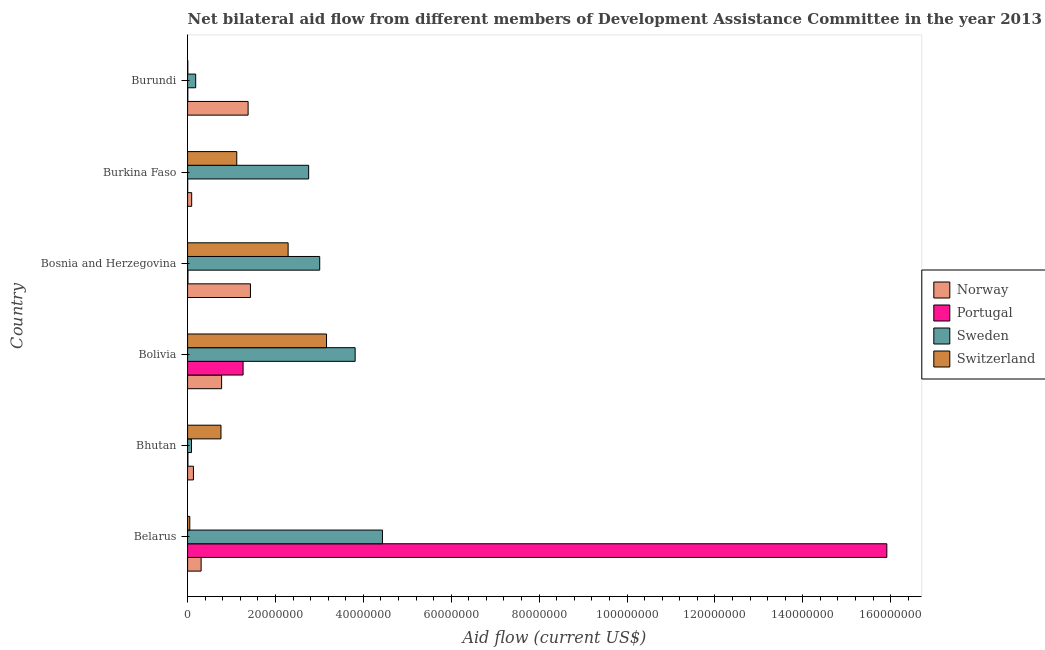How many different coloured bars are there?
Offer a very short reply. 4. How many bars are there on the 4th tick from the top?
Keep it short and to the point. 4. What is the label of the 1st group of bars from the top?
Your answer should be very brief. Burundi. What is the amount of aid given by sweden in Belarus?
Provide a short and direct response. 4.43e+07. Across all countries, what is the maximum amount of aid given by switzerland?
Your answer should be compact. 3.16e+07. Across all countries, what is the minimum amount of aid given by portugal?
Keep it short and to the point. 2.00e+04. In which country was the amount of aid given by sweden maximum?
Your response must be concise. Belarus. In which country was the amount of aid given by sweden minimum?
Provide a short and direct response. Bhutan. What is the total amount of aid given by norway in the graph?
Your response must be concise. 4.12e+07. What is the difference between the amount of aid given by portugal in Bolivia and that in Burkina Faso?
Your answer should be compact. 1.26e+07. What is the difference between the amount of aid given by switzerland in Bosnia and Herzegovina and the amount of aid given by norway in Bolivia?
Give a very brief answer. 1.51e+07. What is the average amount of aid given by sweden per country?
Ensure brevity in your answer.  2.38e+07. What is the difference between the amount of aid given by portugal and amount of aid given by norway in Burundi?
Offer a terse response. -1.37e+07. In how many countries, is the amount of aid given by sweden greater than 80000000 US$?
Ensure brevity in your answer.  0. What is the ratio of the amount of aid given by switzerland in Belarus to that in Bolivia?
Keep it short and to the point. 0.02. Is the amount of aid given by portugal in Bolivia less than that in Burkina Faso?
Make the answer very short. No. Is the difference between the amount of aid given by portugal in Burkina Faso and Burundi greater than the difference between the amount of aid given by switzerland in Burkina Faso and Burundi?
Your answer should be compact. No. What is the difference between the highest and the second highest amount of aid given by sweden?
Your answer should be very brief. 6.21e+06. What is the difference between the highest and the lowest amount of aid given by sweden?
Ensure brevity in your answer.  4.34e+07. In how many countries, is the amount of aid given by norway greater than the average amount of aid given by norway taken over all countries?
Make the answer very short. 3. What does the 1st bar from the top in Belarus represents?
Your answer should be very brief. Switzerland. Is it the case that in every country, the sum of the amount of aid given by norway and amount of aid given by portugal is greater than the amount of aid given by sweden?
Give a very brief answer. No. How many bars are there?
Ensure brevity in your answer.  24. How many countries are there in the graph?
Make the answer very short. 6. What is the difference between two consecutive major ticks on the X-axis?
Your response must be concise. 2.00e+07. Are the values on the major ticks of X-axis written in scientific E-notation?
Your response must be concise. No. Does the graph contain any zero values?
Your answer should be very brief. No. How many legend labels are there?
Your response must be concise. 4. What is the title of the graph?
Your answer should be very brief. Net bilateral aid flow from different members of Development Assistance Committee in the year 2013. Does "Korea" appear as one of the legend labels in the graph?
Your response must be concise. No. What is the label or title of the X-axis?
Offer a terse response. Aid flow (current US$). What is the Aid flow (current US$) of Norway in Belarus?
Give a very brief answer. 3.08e+06. What is the Aid flow (current US$) in Portugal in Belarus?
Provide a succinct answer. 1.59e+08. What is the Aid flow (current US$) in Sweden in Belarus?
Keep it short and to the point. 4.43e+07. What is the Aid flow (current US$) of Switzerland in Belarus?
Your answer should be very brief. 5.00e+05. What is the Aid flow (current US$) in Norway in Bhutan?
Your response must be concise. 1.33e+06. What is the Aid flow (current US$) of Portugal in Bhutan?
Offer a very short reply. 7.00e+04. What is the Aid flow (current US$) in Sweden in Bhutan?
Your response must be concise. 8.90e+05. What is the Aid flow (current US$) of Switzerland in Bhutan?
Provide a short and direct response. 7.60e+06. What is the Aid flow (current US$) in Norway in Bolivia?
Provide a short and direct response. 7.74e+06. What is the Aid flow (current US$) of Portugal in Bolivia?
Offer a terse response. 1.26e+07. What is the Aid flow (current US$) of Sweden in Bolivia?
Offer a very short reply. 3.81e+07. What is the Aid flow (current US$) in Switzerland in Bolivia?
Give a very brief answer. 3.16e+07. What is the Aid flow (current US$) in Norway in Bosnia and Herzegovina?
Keep it short and to the point. 1.43e+07. What is the Aid flow (current US$) of Portugal in Bosnia and Herzegovina?
Your answer should be compact. 8.00e+04. What is the Aid flow (current US$) of Sweden in Bosnia and Herzegovina?
Provide a short and direct response. 3.01e+07. What is the Aid flow (current US$) of Switzerland in Bosnia and Herzegovina?
Your response must be concise. 2.29e+07. What is the Aid flow (current US$) in Norway in Burkina Faso?
Ensure brevity in your answer.  9.30e+05. What is the Aid flow (current US$) of Sweden in Burkina Faso?
Offer a terse response. 2.76e+07. What is the Aid flow (current US$) in Switzerland in Burkina Faso?
Ensure brevity in your answer.  1.12e+07. What is the Aid flow (current US$) in Norway in Burundi?
Offer a very short reply. 1.38e+07. What is the Aid flow (current US$) in Sweden in Burundi?
Give a very brief answer. 1.84e+06. What is the Aid flow (current US$) of Switzerland in Burundi?
Keep it short and to the point. 5.00e+04. Across all countries, what is the maximum Aid flow (current US$) of Norway?
Ensure brevity in your answer.  1.43e+07. Across all countries, what is the maximum Aid flow (current US$) in Portugal?
Offer a terse response. 1.59e+08. Across all countries, what is the maximum Aid flow (current US$) in Sweden?
Provide a short and direct response. 4.43e+07. Across all countries, what is the maximum Aid flow (current US$) in Switzerland?
Give a very brief answer. 3.16e+07. Across all countries, what is the minimum Aid flow (current US$) of Norway?
Give a very brief answer. 9.30e+05. Across all countries, what is the minimum Aid flow (current US$) of Sweden?
Offer a terse response. 8.90e+05. Across all countries, what is the minimum Aid flow (current US$) in Switzerland?
Give a very brief answer. 5.00e+04. What is the total Aid flow (current US$) of Norway in the graph?
Your answer should be compact. 4.12e+07. What is the total Aid flow (current US$) in Portugal in the graph?
Your answer should be very brief. 1.72e+08. What is the total Aid flow (current US$) of Sweden in the graph?
Your answer should be very brief. 1.43e+08. What is the total Aid flow (current US$) of Switzerland in the graph?
Ensure brevity in your answer.  7.38e+07. What is the difference between the Aid flow (current US$) in Norway in Belarus and that in Bhutan?
Your answer should be compact. 1.75e+06. What is the difference between the Aid flow (current US$) in Portugal in Belarus and that in Bhutan?
Your answer should be very brief. 1.59e+08. What is the difference between the Aid flow (current US$) in Sweden in Belarus and that in Bhutan?
Your answer should be very brief. 4.34e+07. What is the difference between the Aid flow (current US$) in Switzerland in Belarus and that in Bhutan?
Make the answer very short. -7.10e+06. What is the difference between the Aid flow (current US$) in Norway in Belarus and that in Bolivia?
Ensure brevity in your answer.  -4.66e+06. What is the difference between the Aid flow (current US$) in Portugal in Belarus and that in Bolivia?
Your answer should be very brief. 1.46e+08. What is the difference between the Aid flow (current US$) in Sweden in Belarus and that in Bolivia?
Provide a succinct answer. 6.21e+06. What is the difference between the Aid flow (current US$) in Switzerland in Belarus and that in Bolivia?
Keep it short and to the point. -3.11e+07. What is the difference between the Aid flow (current US$) in Norway in Belarus and that in Bosnia and Herzegovina?
Ensure brevity in your answer.  -1.12e+07. What is the difference between the Aid flow (current US$) in Portugal in Belarus and that in Bosnia and Herzegovina?
Your answer should be very brief. 1.59e+08. What is the difference between the Aid flow (current US$) in Sweden in Belarus and that in Bosnia and Herzegovina?
Give a very brief answer. 1.43e+07. What is the difference between the Aid flow (current US$) in Switzerland in Belarus and that in Bosnia and Herzegovina?
Make the answer very short. -2.24e+07. What is the difference between the Aid flow (current US$) in Norway in Belarus and that in Burkina Faso?
Offer a very short reply. 2.15e+06. What is the difference between the Aid flow (current US$) in Portugal in Belarus and that in Burkina Faso?
Make the answer very short. 1.59e+08. What is the difference between the Aid flow (current US$) of Sweden in Belarus and that in Burkina Faso?
Your answer should be compact. 1.68e+07. What is the difference between the Aid flow (current US$) in Switzerland in Belarus and that in Burkina Faso?
Ensure brevity in your answer.  -1.07e+07. What is the difference between the Aid flow (current US$) of Norway in Belarus and that in Burundi?
Your answer should be very brief. -1.07e+07. What is the difference between the Aid flow (current US$) of Portugal in Belarus and that in Burundi?
Your answer should be very brief. 1.59e+08. What is the difference between the Aid flow (current US$) of Sweden in Belarus and that in Burundi?
Ensure brevity in your answer.  4.25e+07. What is the difference between the Aid flow (current US$) of Norway in Bhutan and that in Bolivia?
Ensure brevity in your answer.  -6.41e+06. What is the difference between the Aid flow (current US$) of Portugal in Bhutan and that in Bolivia?
Provide a short and direct response. -1.26e+07. What is the difference between the Aid flow (current US$) of Sweden in Bhutan and that in Bolivia?
Your answer should be compact. -3.72e+07. What is the difference between the Aid flow (current US$) in Switzerland in Bhutan and that in Bolivia?
Make the answer very short. -2.40e+07. What is the difference between the Aid flow (current US$) of Norway in Bhutan and that in Bosnia and Herzegovina?
Your answer should be compact. -1.30e+07. What is the difference between the Aid flow (current US$) in Portugal in Bhutan and that in Bosnia and Herzegovina?
Ensure brevity in your answer.  -10000. What is the difference between the Aid flow (current US$) of Sweden in Bhutan and that in Bosnia and Herzegovina?
Offer a very short reply. -2.92e+07. What is the difference between the Aid flow (current US$) of Switzerland in Bhutan and that in Bosnia and Herzegovina?
Ensure brevity in your answer.  -1.53e+07. What is the difference between the Aid flow (current US$) in Norway in Bhutan and that in Burkina Faso?
Offer a terse response. 4.00e+05. What is the difference between the Aid flow (current US$) of Sweden in Bhutan and that in Burkina Faso?
Ensure brevity in your answer.  -2.67e+07. What is the difference between the Aid flow (current US$) in Switzerland in Bhutan and that in Burkina Faso?
Offer a terse response. -3.59e+06. What is the difference between the Aid flow (current US$) in Norway in Bhutan and that in Burundi?
Ensure brevity in your answer.  -1.24e+07. What is the difference between the Aid flow (current US$) in Sweden in Bhutan and that in Burundi?
Offer a terse response. -9.50e+05. What is the difference between the Aid flow (current US$) of Switzerland in Bhutan and that in Burundi?
Your answer should be very brief. 7.55e+06. What is the difference between the Aid flow (current US$) of Norway in Bolivia and that in Bosnia and Herzegovina?
Offer a terse response. -6.57e+06. What is the difference between the Aid flow (current US$) in Portugal in Bolivia and that in Bosnia and Herzegovina?
Provide a short and direct response. 1.26e+07. What is the difference between the Aid flow (current US$) in Sweden in Bolivia and that in Bosnia and Herzegovina?
Provide a succinct answer. 8.06e+06. What is the difference between the Aid flow (current US$) in Switzerland in Bolivia and that in Bosnia and Herzegovina?
Your answer should be compact. 8.74e+06. What is the difference between the Aid flow (current US$) in Norway in Bolivia and that in Burkina Faso?
Provide a succinct answer. 6.81e+06. What is the difference between the Aid flow (current US$) in Portugal in Bolivia and that in Burkina Faso?
Your response must be concise. 1.26e+07. What is the difference between the Aid flow (current US$) in Sweden in Bolivia and that in Burkina Faso?
Give a very brief answer. 1.06e+07. What is the difference between the Aid flow (current US$) of Switzerland in Bolivia and that in Burkina Faso?
Provide a short and direct response. 2.04e+07. What is the difference between the Aid flow (current US$) of Norway in Bolivia and that in Burundi?
Your answer should be very brief. -6.03e+06. What is the difference between the Aid flow (current US$) in Portugal in Bolivia and that in Burundi?
Your response must be concise. 1.26e+07. What is the difference between the Aid flow (current US$) in Sweden in Bolivia and that in Burundi?
Keep it short and to the point. 3.63e+07. What is the difference between the Aid flow (current US$) of Switzerland in Bolivia and that in Burundi?
Give a very brief answer. 3.16e+07. What is the difference between the Aid flow (current US$) of Norway in Bosnia and Herzegovina and that in Burkina Faso?
Your answer should be compact. 1.34e+07. What is the difference between the Aid flow (current US$) in Portugal in Bosnia and Herzegovina and that in Burkina Faso?
Keep it short and to the point. 6.00e+04. What is the difference between the Aid flow (current US$) in Sweden in Bosnia and Herzegovina and that in Burkina Faso?
Offer a very short reply. 2.52e+06. What is the difference between the Aid flow (current US$) in Switzerland in Bosnia and Herzegovina and that in Burkina Faso?
Your answer should be compact. 1.17e+07. What is the difference between the Aid flow (current US$) of Norway in Bosnia and Herzegovina and that in Burundi?
Give a very brief answer. 5.40e+05. What is the difference between the Aid flow (current US$) in Sweden in Bosnia and Herzegovina and that in Burundi?
Give a very brief answer. 2.82e+07. What is the difference between the Aid flow (current US$) in Switzerland in Bosnia and Herzegovina and that in Burundi?
Make the answer very short. 2.28e+07. What is the difference between the Aid flow (current US$) in Norway in Burkina Faso and that in Burundi?
Offer a very short reply. -1.28e+07. What is the difference between the Aid flow (current US$) of Portugal in Burkina Faso and that in Burundi?
Your answer should be compact. -3.00e+04. What is the difference between the Aid flow (current US$) of Sweden in Burkina Faso and that in Burundi?
Make the answer very short. 2.57e+07. What is the difference between the Aid flow (current US$) of Switzerland in Burkina Faso and that in Burundi?
Offer a terse response. 1.11e+07. What is the difference between the Aid flow (current US$) of Norway in Belarus and the Aid flow (current US$) of Portugal in Bhutan?
Your response must be concise. 3.01e+06. What is the difference between the Aid flow (current US$) in Norway in Belarus and the Aid flow (current US$) in Sweden in Bhutan?
Offer a very short reply. 2.19e+06. What is the difference between the Aid flow (current US$) of Norway in Belarus and the Aid flow (current US$) of Switzerland in Bhutan?
Your answer should be compact. -4.52e+06. What is the difference between the Aid flow (current US$) in Portugal in Belarus and the Aid flow (current US$) in Sweden in Bhutan?
Offer a terse response. 1.58e+08. What is the difference between the Aid flow (current US$) of Portugal in Belarus and the Aid flow (current US$) of Switzerland in Bhutan?
Offer a very short reply. 1.52e+08. What is the difference between the Aid flow (current US$) in Sweden in Belarus and the Aid flow (current US$) in Switzerland in Bhutan?
Your response must be concise. 3.67e+07. What is the difference between the Aid flow (current US$) of Norway in Belarus and the Aid flow (current US$) of Portugal in Bolivia?
Your response must be concise. -9.55e+06. What is the difference between the Aid flow (current US$) of Norway in Belarus and the Aid flow (current US$) of Sweden in Bolivia?
Give a very brief answer. -3.50e+07. What is the difference between the Aid flow (current US$) of Norway in Belarus and the Aid flow (current US$) of Switzerland in Bolivia?
Offer a very short reply. -2.85e+07. What is the difference between the Aid flow (current US$) of Portugal in Belarus and the Aid flow (current US$) of Sweden in Bolivia?
Your answer should be very brief. 1.21e+08. What is the difference between the Aid flow (current US$) in Portugal in Belarus and the Aid flow (current US$) in Switzerland in Bolivia?
Ensure brevity in your answer.  1.28e+08. What is the difference between the Aid flow (current US$) of Sweden in Belarus and the Aid flow (current US$) of Switzerland in Bolivia?
Your response must be concise. 1.27e+07. What is the difference between the Aid flow (current US$) of Norway in Belarus and the Aid flow (current US$) of Sweden in Bosnia and Herzegovina?
Offer a terse response. -2.70e+07. What is the difference between the Aid flow (current US$) in Norway in Belarus and the Aid flow (current US$) in Switzerland in Bosnia and Herzegovina?
Keep it short and to the point. -1.98e+07. What is the difference between the Aid flow (current US$) in Portugal in Belarus and the Aid flow (current US$) in Sweden in Bosnia and Herzegovina?
Keep it short and to the point. 1.29e+08. What is the difference between the Aid flow (current US$) of Portugal in Belarus and the Aid flow (current US$) of Switzerland in Bosnia and Herzegovina?
Your response must be concise. 1.36e+08. What is the difference between the Aid flow (current US$) in Sweden in Belarus and the Aid flow (current US$) in Switzerland in Bosnia and Herzegovina?
Your answer should be very brief. 2.15e+07. What is the difference between the Aid flow (current US$) of Norway in Belarus and the Aid flow (current US$) of Portugal in Burkina Faso?
Your response must be concise. 3.06e+06. What is the difference between the Aid flow (current US$) in Norway in Belarus and the Aid flow (current US$) in Sweden in Burkina Faso?
Provide a succinct answer. -2.45e+07. What is the difference between the Aid flow (current US$) in Norway in Belarus and the Aid flow (current US$) in Switzerland in Burkina Faso?
Your response must be concise. -8.11e+06. What is the difference between the Aid flow (current US$) of Portugal in Belarus and the Aid flow (current US$) of Sweden in Burkina Faso?
Ensure brevity in your answer.  1.32e+08. What is the difference between the Aid flow (current US$) of Portugal in Belarus and the Aid flow (current US$) of Switzerland in Burkina Faso?
Give a very brief answer. 1.48e+08. What is the difference between the Aid flow (current US$) of Sweden in Belarus and the Aid flow (current US$) of Switzerland in Burkina Faso?
Your response must be concise. 3.32e+07. What is the difference between the Aid flow (current US$) of Norway in Belarus and the Aid flow (current US$) of Portugal in Burundi?
Ensure brevity in your answer.  3.03e+06. What is the difference between the Aid flow (current US$) in Norway in Belarus and the Aid flow (current US$) in Sweden in Burundi?
Ensure brevity in your answer.  1.24e+06. What is the difference between the Aid flow (current US$) of Norway in Belarus and the Aid flow (current US$) of Switzerland in Burundi?
Ensure brevity in your answer.  3.03e+06. What is the difference between the Aid flow (current US$) in Portugal in Belarus and the Aid flow (current US$) in Sweden in Burundi?
Provide a succinct answer. 1.57e+08. What is the difference between the Aid flow (current US$) in Portugal in Belarus and the Aid flow (current US$) in Switzerland in Burundi?
Your answer should be compact. 1.59e+08. What is the difference between the Aid flow (current US$) in Sweden in Belarus and the Aid flow (current US$) in Switzerland in Burundi?
Make the answer very short. 4.43e+07. What is the difference between the Aid flow (current US$) of Norway in Bhutan and the Aid flow (current US$) of Portugal in Bolivia?
Give a very brief answer. -1.13e+07. What is the difference between the Aid flow (current US$) in Norway in Bhutan and the Aid flow (current US$) in Sweden in Bolivia?
Provide a short and direct response. -3.68e+07. What is the difference between the Aid flow (current US$) in Norway in Bhutan and the Aid flow (current US$) in Switzerland in Bolivia?
Offer a very short reply. -3.03e+07. What is the difference between the Aid flow (current US$) of Portugal in Bhutan and the Aid flow (current US$) of Sweden in Bolivia?
Provide a short and direct response. -3.81e+07. What is the difference between the Aid flow (current US$) of Portugal in Bhutan and the Aid flow (current US$) of Switzerland in Bolivia?
Your answer should be compact. -3.16e+07. What is the difference between the Aid flow (current US$) in Sweden in Bhutan and the Aid flow (current US$) in Switzerland in Bolivia?
Give a very brief answer. -3.07e+07. What is the difference between the Aid flow (current US$) of Norway in Bhutan and the Aid flow (current US$) of Portugal in Bosnia and Herzegovina?
Ensure brevity in your answer.  1.25e+06. What is the difference between the Aid flow (current US$) in Norway in Bhutan and the Aid flow (current US$) in Sweden in Bosnia and Herzegovina?
Offer a very short reply. -2.87e+07. What is the difference between the Aid flow (current US$) in Norway in Bhutan and the Aid flow (current US$) in Switzerland in Bosnia and Herzegovina?
Give a very brief answer. -2.16e+07. What is the difference between the Aid flow (current US$) of Portugal in Bhutan and the Aid flow (current US$) of Sweden in Bosnia and Herzegovina?
Ensure brevity in your answer.  -3.00e+07. What is the difference between the Aid flow (current US$) of Portugal in Bhutan and the Aid flow (current US$) of Switzerland in Bosnia and Herzegovina?
Offer a terse response. -2.28e+07. What is the difference between the Aid flow (current US$) of Sweden in Bhutan and the Aid flow (current US$) of Switzerland in Bosnia and Herzegovina?
Make the answer very short. -2.20e+07. What is the difference between the Aid flow (current US$) in Norway in Bhutan and the Aid flow (current US$) in Portugal in Burkina Faso?
Your response must be concise. 1.31e+06. What is the difference between the Aid flow (current US$) in Norway in Bhutan and the Aid flow (current US$) in Sweden in Burkina Faso?
Give a very brief answer. -2.62e+07. What is the difference between the Aid flow (current US$) in Norway in Bhutan and the Aid flow (current US$) in Switzerland in Burkina Faso?
Your answer should be compact. -9.86e+06. What is the difference between the Aid flow (current US$) of Portugal in Bhutan and the Aid flow (current US$) of Sweden in Burkina Faso?
Ensure brevity in your answer.  -2.75e+07. What is the difference between the Aid flow (current US$) in Portugal in Bhutan and the Aid flow (current US$) in Switzerland in Burkina Faso?
Ensure brevity in your answer.  -1.11e+07. What is the difference between the Aid flow (current US$) in Sweden in Bhutan and the Aid flow (current US$) in Switzerland in Burkina Faso?
Offer a very short reply. -1.03e+07. What is the difference between the Aid flow (current US$) of Norway in Bhutan and the Aid flow (current US$) of Portugal in Burundi?
Provide a short and direct response. 1.28e+06. What is the difference between the Aid flow (current US$) of Norway in Bhutan and the Aid flow (current US$) of Sweden in Burundi?
Make the answer very short. -5.10e+05. What is the difference between the Aid flow (current US$) in Norway in Bhutan and the Aid flow (current US$) in Switzerland in Burundi?
Ensure brevity in your answer.  1.28e+06. What is the difference between the Aid flow (current US$) in Portugal in Bhutan and the Aid flow (current US$) in Sweden in Burundi?
Provide a short and direct response. -1.77e+06. What is the difference between the Aid flow (current US$) in Portugal in Bhutan and the Aid flow (current US$) in Switzerland in Burundi?
Your response must be concise. 2.00e+04. What is the difference between the Aid flow (current US$) of Sweden in Bhutan and the Aid flow (current US$) of Switzerland in Burundi?
Offer a very short reply. 8.40e+05. What is the difference between the Aid flow (current US$) of Norway in Bolivia and the Aid flow (current US$) of Portugal in Bosnia and Herzegovina?
Your response must be concise. 7.66e+06. What is the difference between the Aid flow (current US$) of Norway in Bolivia and the Aid flow (current US$) of Sweden in Bosnia and Herzegovina?
Offer a very short reply. -2.23e+07. What is the difference between the Aid flow (current US$) of Norway in Bolivia and the Aid flow (current US$) of Switzerland in Bosnia and Herzegovina?
Give a very brief answer. -1.51e+07. What is the difference between the Aid flow (current US$) of Portugal in Bolivia and the Aid flow (current US$) of Sweden in Bosnia and Herzegovina?
Keep it short and to the point. -1.74e+07. What is the difference between the Aid flow (current US$) in Portugal in Bolivia and the Aid flow (current US$) in Switzerland in Bosnia and Herzegovina?
Offer a very short reply. -1.02e+07. What is the difference between the Aid flow (current US$) in Sweden in Bolivia and the Aid flow (current US$) in Switzerland in Bosnia and Herzegovina?
Keep it short and to the point. 1.52e+07. What is the difference between the Aid flow (current US$) in Norway in Bolivia and the Aid flow (current US$) in Portugal in Burkina Faso?
Provide a succinct answer. 7.72e+06. What is the difference between the Aid flow (current US$) in Norway in Bolivia and the Aid flow (current US$) in Sweden in Burkina Faso?
Make the answer very short. -1.98e+07. What is the difference between the Aid flow (current US$) in Norway in Bolivia and the Aid flow (current US$) in Switzerland in Burkina Faso?
Provide a short and direct response. -3.45e+06. What is the difference between the Aid flow (current US$) in Portugal in Bolivia and the Aid flow (current US$) in Sweden in Burkina Faso?
Your response must be concise. -1.49e+07. What is the difference between the Aid flow (current US$) in Portugal in Bolivia and the Aid flow (current US$) in Switzerland in Burkina Faso?
Ensure brevity in your answer.  1.44e+06. What is the difference between the Aid flow (current US$) in Sweden in Bolivia and the Aid flow (current US$) in Switzerland in Burkina Faso?
Your answer should be compact. 2.69e+07. What is the difference between the Aid flow (current US$) of Norway in Bolivia and the Aid flow (current US$) of Portugal in Burundi?
Your response must be concise. 7.69e+06. What is the difference between the Aid flow (current US$) in Norway in Bolivia and the Aid flow (current US$) in Sweden in Burundi?
Your answer should be very brief. 5.90e+06. What is the difference between the Aid flow (current US$) of Norway in Bolivia and the Aid flow (current US$) of Switzerland in Burundi?
Make the answer very short. 7.69e+06. What is the difference between the Aid flow (current US$) in Portugal in Bolivia and the Aid flow (current US$) in Sweden in Burundi?
Your answer should be very brief. 1.08e+07. What is the difference between the Aid flow (current US$) of Portugal in Bolivia and the Aid flow (current US$) of Switzerland in Burundi?
Offer a terse response. 1.26e+07. What is the difference between the Aid flow (current US$) of Sweden in Bolivia and the Aid flow (current US$) of Switzerland in Burundi?
Provide a short and direct response. 3.81e+07. What is the difference between the Aid flow (current US$) in Norway in Bosnia and Herzegovina and the Aid flow (current US$) in Portugal in Burkina Faso?
Keep it short and to the point. 1.43e+07. What is the difference between the Aid flow (current US$) of Norway in Bosnia and Herzegovina and the Aid flow (current US$) of Sweden in Burkina Faso?
Give a very brief answer. -1.32e+07. What is the difference between the Aid flow (current US$) of Norway in Bosnia and Herzegovina and the Aid flow (current US$) of Switzerland in Burkina Faso?
Ensure brevity in your answer.  3.12e+06. What is the difference between the Aid flow (current US$) in Portugal in Bosnia and Herzegovina and the Aid flow (current US$) in Sweden in Burkina Faso?
Offer a terse response. -2.75e+07. What is the difference between the Aid flow (current US$) of Portugal in Bosnia and Herzegovina and the Aid flow (current US$) of Switzerland in Burkina Faso?
Offer a very short reply. -1.11e+07. What is the difference between the Aid flow (current US$) of Sweden in Bosnia and Herzegovina and the Aid flow (current US$) of Switzerland in Burkina Faso?
Offer a very short reply. 1.89e+07. What is the difference between the Aid flow (current US$) of Norway in Bosnia and Herzegovina and the Aid flow (current US$) of Portugal in Burundi?
Your answer should be compact. 1.43e+07. What is the difference between the Aid flow (current US$) in Norway in Bosnia and Herzegovina and the Aid flow (current US$) in Sweden in Burundi?
Make the answer very short. 1.25e+07. What is the difference between the Aid flow (current US$) in Norway in Bosnia and Herzegovina and the Aid flow (current US$) in Switzerland in Burundi?
Ensure brevity in your answer.  1.43e+07. What is the difference between the Aid flow (current US$) in Portugal in Bosnia and Herzegovina and the Aid flow (current US$) in Sweden in Burundi?
Make the answer very short. -1.76e+06. What is the difference between the Aid flow (current US$) of Portugal in Bosnia and Herzegovina and the Aid flow (current US$) of Switzerland in Burundi?
Your response must be concise. 3.00e+04. What is the difference between the Aid flow (current US$) in Sweden in Bosnia and Herzegovina and the Aid flow (current US$) in Switzerland in Burundi?
Ensure brevity in your answer.  3.00e+07. What is the difference between the Aid flow (current US$) in Norway in Burkina Faso and the Aid flow (current US$) in Portugal in Burundi?
Give a very brief answer. 8.80e+05. What is the difference between the Aid flow (current US$) of Norway in Burkina Faso and the Aid flow (current US$) of Sweden in Burundi?
Keep it short and to the point. -9.10e+05. What is the difference between the Aid flow (current US$) of Norway in Burkina Faso and the Aid flow (current US$) of Switzerland in Burundi?
Your answer should be very brief. 8.80e+05. What is the difference between the Aid flow (current US$) in Portugal in Burkina Faso and the Aid flow (current US$) in Sweden in Burundi?
Your response must be concise. -1.82e+06. What is the difference between the Aid flow (current US$) in Portugal in Burkina Faso and the Aid flow (current US$) in Switzerland in Burundi?
Provide a succinct answer. -3.00e+04. What is the difference between the Aid flow (current US$) in Sweden in Burkina Faso and the Aid flow (current US$) in Switzerland in Burundi?
Offer a terse response. 2.75e+07. What is the average Aid flow (current US$) of Norway per country?
Offer a terse response. 6.86e+06. What is the average Aid flow (current US$) in Portugal per country?
Ensure brevity in your answer.  2.87e+07. What is the average Aid flow (current US$) of Sweden per country?
Your answer should be compact. 2.38e+07. What is the average Aid flow (current US$) in Switzerland per country?
Offer a very short reply. 1.23e+07. What is the difference between the Aid flow (current US$) in Norway and Aid flow (current US$) in Portugal in Belarus?
Make the answer very short. -1.56e+08. What is the difference between the Aid flow (current US$) in Norway and Aid flow (current US$) in Sweden in Belarus?
Ensure brevity in your answer.  -4.13e+07. What is the difference between the Aid flow (current US$) in Norway and Aid flow (current US$) in Switzerland in Belarus?
Give a very brief answer. 2.58e+06. What is the difference between the Aid flow (current US$) of Portugal and Aid flow (current US$) of Sweden in Belarus?
Provide a short and direct response. 1.15e+08. What is the difference between the Aid flow (current US$) in Portugal and Aid flow (current US$) in Switzerland in Belarus?
Make the answer very short. 1.59e+08. What is the difference between the Aid flow (current US$) of Sweden and Aid flow (current US$) of Switzerland in Belarus?
Provide a short and direct response. 4.38e+07. What is the difference between the Aid flow (current US$) of Norway and Aid flow (current US$) of Portugal in Bhutan?
Offer a terse response. 1.26e+06. What is the difference between the Aid flow (current US$) of Norway and Aid flow (current US$) of Switzerland in Bhutan?
Offer a terse response. -6.27e+06. What is the difference between the Aid flow (current US$) in Portugal and Aid flow (current US$) in Sweden in Bhutan?
Your response must be concise. -8.20e+05. What is the difference between the Aid flow (current US$) of Portugal and Aid flow (current US$) of Switzerland in Bhutan?
Your answer should be very brief. -7.53e+06. What is the difference between the Aid flow (current US$) of Sweden and Aid flow (current US$) of Switzerland in Bhutan?
Your response must be concise. -6.71e+06. What is the difference between the Aid flow (current US$) of Norway and Aid flow (current US$) of Portugal in Bolivia?
Ensure brevity in your answer.  -4.89e+06. What is the difference between the Aid flow (current US$) in Norway and Aid flow (current US$) in Sweden in Bolivia?
Your response must be concise. -3.04e+07. What is the difference between the Aid flow (current US$) of Norway and Aid flow (current US$) of Switzerland in Bolivia?
Your answer should be compact. -2.39e+07. What is the difference between the Aid flow (current US$) of Portugal and Aid flow (current US$) of Sweden in Bolivia?
Provide a succinct answer. -2.55e+07. What is the difference between the Aid flow (current US$) of Portugal and Aid flow (current US$) of Switzerland in Bolivia?
Give a very brief answer. -1.90e+07. What is the difference between the Aid flow (current US$) of Sweden and Aid flow (current US$) of Switzerland in Bolivia?
Ensure brevity in your answer.  6.51e+06. What is the difference between the Aid flow (current US$) of Norway and Aid flow (current US$) of Portugal in Bosnia and Herzegovina?
Provide a succinct answer. 1.42e+07. What is the difference between the Aid flow (current US$) of Norway and Aid flow (current US$) of Sweden in Bosnia and Herzegovina?
Offer a very short reply. -1.58e+07. What is the difference between the Aid flow (current US$) of Norway and Aid flow (current US$) of Switzerland in Bosnia and Herzegovina?
Ensure brevity in your answer.  -8.57e+06. What is the difference between the Aid flow (current US$) in Portugal and Aid flow (current US$) in Sweden in Bosnia and Herzegovina?
Offer a very short reply. -3.00e+07. What is the difference between the Aid flow (current US$) in Portugal and Aid flow (current US$) in Switzerland in Bosnia and Herzegovina?
Your answer should be compact. -2.28e+07. What is the difference between the Aid flow (current US$) in Sweden and Aid flow (current US$) in Switzerland in Bosnia and Herzegovina?
Offer a terse response. 7.19e+06. What is the difference between the Aid flow (current US$) of Norway and Aid flow (current US$) of Portugal in Burkina Faso?
Your answer should be compact. 9.10e+05. What is the difference between the Aid flow (current US$) of Norway and Aid flow (current US$) of Sweden in Burkina Faso?
Your answer should be compact. -2.66e+07. What is the difference between the Aid flow (current US$) of Norway and Aid flow (current US$) of Switzerland in Burkina Faso?
Your answer should be compact. -1.03e+07. What is the difference between the Aid flow (current US$) of Portugal and Aid flow (current US$) of Sweden in Burkina Faso?
Keep it short and to the point. -2.75e+07. What is the difference between the Aid flow (current US$) of Portugal and Aid flow (current US$) of Switzerland in Burkina Faso?
Your answer should be very brief. -1.12e+07. What is the difference between the Aid flow (current US$) of Sweden and Aid flow (current US$) of Switzerland in Burkina Faso?
Offer a terse response. 1.64e+07. What is the difference between the Aid flow (current US$) of Norway and Aid flow (current US$) of Portugal in Burundi?
Provide a short and direct response. 1.37e+07. What is the difference between the Aid flow (current US$) in Norway and Aid flow (current US$) in Sweden in Burundi?
Ensure brevity in your answer.  1.19e+07. What is the difference between the Aid flow (current US$) in Norway and Aid flow (current US$) in Switzerland in Burundi?
Offer a terse response. 1.37e+07. What is the difference between the Aid flow (current US$) of Portugal and Aid flow (current US$) of Sweden in Burundi?
Keep it short and to the point. -1.79e+06. What is the difference between the Aid flow (current US$) of Portugal and Aid flow (current US$) of Switzerland in Burundi?
Your response must be concise. 0. What is the difference between the Aid flow (current US$) of Sweden and Aid flow (current US$) of Switzerland in Burundi?
Your answer should be very brief. 1.79e+06. What is the ratio of the Aid flow (current US$) of Norway in Belarus to that in Bhutan?
Keep it short and to the point. 2.32. What is the ratio of the Aid flow (current US$) in Portugal in Belarus to that in Bhutan?
Give a very brief answer. 2273.29. What is the ratio of the Aid flow (current US$) in Sweden in Belarus to that in Bhutan?
Make the answer very short. 49.82. What is the ratio of the Aid flow (current US$) of Switzerland in Belarus to that in Bhutan?
Your answer should be compact. 0.07. What is the ratio of the Aid flow (current US$) in Norway in Belarus to that in Bolivia?
Give a very brief answer. 0.4. What is the ratio of the Aid flow (current US$) of Portugal in Belarus to that in Bolivia?
Keep it short and to the point. 12.6. What is the ratio of the Aid flow (current US$) of Sweden in Belarus to that in Bolivia?
Your response must be concise. 1.16. What is the ratio of the Aid flow (current US$) in Switzerland in Belarus to that in Bolivia?
Make the answer very short. 0.02. What is the ratio of the Aid flow (current US$) in Norway in Belarus to that in Bosnia and Herzegovina?
Give a very brief answer. 0.22. What is the ratio of the Aid flow (current US$) of Portugal in Belarus to that in Bosnia and Herzegovina?
Your answer should be very brief. 1989.12. What is the ratio of the Aid flow (current US$) of Sweden in Belarus to that in Bosnia and Herzegovina?
Offer a terse response. 1.47. What is the ratio of the Aid flow (current US$) in Switzerland in Belarus to that in Bosnia and Herzegovina?
Your response must be concise. 0.02. What is the ratio of the Aid flow (current US$) in Norway in Belarus to that in Burkina Faso?
Provide a succinct answer. 3.31. What is the ratio of the Aid flow (current US$) of Portugal in Belarus to that in Burkina Faso?
Provide a short and direct response. 7956.5. What is the ratio of the Aid flow (current US$) in Sweden in Belarus to that in Burkina Faso?
Give a very brief answer. 1.61. What is the ratio of the Aid flow (current US$) of Switzerland in Belarus to that in Burkina Faso?
Offer a very short reply. 0.04. What is the ratio of the Aid flow (current US$) of Norway in Belarus to that in Burundi?
Keep it short and to the point. 0.22. What is the ratio of the Aid flow (current US$) of Portugal in Belarus to that in Burundi?
Your answer should be compact. 3182.6. What is the ratio of the Aid flow (current US$) of Sweden in Belarus to that in Burundi?
Give a very brief answer. 24.1. What is the ratio of the Aid flow (current US$) in Switzerland in Belarus to that in Burundi?
Make the answer very short. 10. What is the ratio of the Aid flow (current US$) in Norway in Bhutan to that in Bolivia?
Offer a very short reply. 0.17. What is the ratio of the Aid flow (current US$) of Portugal in Bhutan to that in Bolivia?
Your answer should be compact. 0.01. What is the ratio of the Aid flow (current US$) of Sweden in Bhutan to that in Bolivia?
Make the answer very short. 0.02. What is the ratio of the Aid flow (current US$) in Switzerland in Bhutan to that in Bolivia?
Your answer should be compact. 0.24. What is the ratio of the Aid flow (current US$) in Norway in Bhutan to that in Bosnia and Herzegovina?
Offer a terse response. 0.09. What is the ratio of the Aid flow (current US$) of Portugal in Bhutan to that in Bosnia and Herzegovina?
Your answer should be very brief. 0.88. What is the ratio of the Aid flow (current US$) in Sweden in Bhutan to that in Bosnia and Herzegovina?
Your response must be concise. 0.03. What is the ratio of the Aid flow (current US$) in Switzerland in Bhutan to that in Bosnia and Herzegovina?
Ensure brevity in your answer.  0.33. What is the ratio of the Aid flow (current US$) in Norway in Bhutan to that in Burkina Faso?
Provide a succinct answer. 1.43. What is the ratio of the Aid flow (current US$) of Sweden in Bhutan to that in Burkina Faso?
Your response must be concise. 0.03. What is the ratio of the Aid flow (current US$) in Switzerland in Bhutan to that in Burkina Faso?
Your answer should be very brief. 0.68. What is the ratio of the Aid flow (current US$) of Norway in Bhutan to that in Burundi?
Offer a very short reply. 0.1. What is the ratio of the Aid flow (current US$) of Sweden in Bhutan to that in Burundi?
Your answer should be very brief. 0.48. What is the ratio of the Aid flow (current US$) in Switzerland in Bhutan to that in Burundi?
Your answer should be compact. 152. What is the ratio of the Aid flow (current US$) in Norway in Bolivia to that in Bosnia and Herzegovina?
Offer a very short reply. 0.54. What is the ratio of the Aid flow (current US$) of Portugal in Bolivia to that in Bosnia and Herzegovina?
Provide a short and direct response. 157.88. What is the ratio of the Aid flow (current US$) of Sweden in Bolivia to that in Bosnia and Herzegovina?
Your answer should be compact. 1.27. What is the ratio of the Aid flow (current US$) in Switzerland in Bolivia to that in Bosnia and Herzegovina?
Provide a short and direct response. 1.38. What is the ratio of the Aid flow (current US$) in Norway in Bolivia to that in Burkina Faso?
Provide a succinct answer. 8.32. What is the ratio of the Aid flow (current US$) in Portugal in Bolivia to that in Burkina Faso?
Keep it short and to the point. 631.5. What is the ratio of the Aid flow (current US$) of Sweden in Bolivia to that in Burkina Faso?
Keep it short and to the point. 1.38. What is the ratio of the Aid flow (current US$) in Switzerland in Bolivia to that in Burkina Faso?
Your answer should be compact. 2.83. What is the ratio of the Aid flow (current US$) in Norway in Bolivia to that in Burundi?
Offer a very short reply. 0.56. What is the ratio of the Aid flow (current US$) in Portugal in Bolivia to that in Burundi?
Make the answer very short. 252.6. What is the ratio of the Aid flow (current US$) of Sweden in Bolivia to that in Burundi?
Keep it short and to the point. 20.72. What is the ratio of the Aid flow (current US$) of Switzerland in Bolivia to that in Burundi?
Offer a terse response. 632.4. What is the ratio of the Aid flow (current US$) in Norway in Bosnia and Herzegovina to that in Burkina Faso?
Your answer should be compact. 15.39. What is the ratio of the Aid flow (current US$) of Portugal in Bosnia and Herzegovina to that in Burkina Faso?
Keep it short and to the point. 4. What is the ratio of the Aid flow (current US$) of Sweden in Bosnia and Herzegovina to that in Burkina Faso?
Your answer should be compact. 1.09. What is the ratio of the Aid flow (current US$) of Switzerland in Bosnia and Herzegovina to that in Burkina Faso?
Provide a succinct answer. 2.04. What is the ratio of the Aid flow (current US$) in Norway in Bosnia and Herzegovina to that in Burundi?
Make the answer very short. 1.04. What is the ratio of the Aid flow (current US$) in Portugal in Bosnia and Herzegovina to that in Burundi?
Provide a short and direct response. 1.6. What is the ratio of the Aid flow (current US$) in Sweden in Bosnia and Herzegovina to that in Burundi?
Offer a terse response. 16.34. What is the ratio of the Aid flow (current US$) of Switzerland in Bosnia and Herzegovina to that in Burundi?
Your answer should be very brief. 457.6. What is the ratio of the Aid flow (current US$) of Norway in Burkina Faso to that in Burundi?
Ensure brevity in your answer.  0.07. What is the ratio of the Aid flow (current US$) of Portugal in Burkina Faso to that in Burundi?
Your answer should be very brief. 0.4. What is the ratio of the Aid flow (current US$) in Sweden in Burkina Faso to that in Burundi?
Make the answer very short. 14.97. What is the ratio of the Aid flow (current US$) of Switzerland in Burkina Faso to that in Burundi?
Offer a very short reply. 223.8. What is the difference between the highest and the second highest Aid flow (current US$) in Norway?
Your response must be concise. 5.40e+05. What is the difference between the highest and the second highest Aid flow (current US$) of Portugal?
Ensure brevity in your answer.  1.46e+08. What is the difference between the highest and the second highest Aid flow (current US$) of Sweden?
Offer a very short reply. 6.21e+06. What is the difference between the highest and the second highest Aid flow (current US$) in Switzerland?
Make the answer very short. 8.74e+06. What is the difference between the highest and the lowest Aid flow (current US$) of Norway?
Ensure brevity in your answer.  1.34e+07. What is the difference between the highest and the lowest Aid flow (current US$) of Portugal?
Provide a short and direct response. 1.59e+08. What is the difference between the highest and the lowest Aid flow (current US$) in Sweden?
Give a very brief answer. 4.34e+07. What is the difference between the highest and the lowest Aid flow (current US$) in Switzerland?
Your answer should be compact. 3.16e+07. 